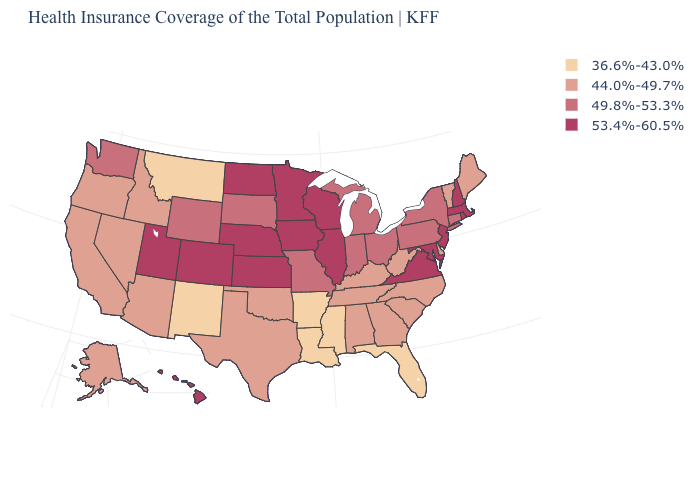Does the map have missing data?
Give a very brief answer. No. Is the legend a continuous bar?
Give a very brief answer. No. What is the value of Hawaii?
Keep it brief. 53.4%-60.5%. What is the value of Alaska?
Concise answer only. 44.0%-49.7%. Does California have the same value as Kentucky?
Answer briefly. Yes. Does the first symbol in the legend represent the smallest category?
Quick response, please. Yes. What is the value of Maryland?
Keep it brief. 53.4%-60.5%. What is the value of New Jersey?
Give a very brief answer. 53.4%-60.5%. What is the lowest value in the USA?
Write a very short answer. 36.6%-43.0%. What is the value of Florida?
Answer briefly. 36.6%-43.0%. Name the states that have a value in the range 36.6%-43.0%?
Concise answer only. Arkansas, Florida, Louisiana, Mississippi, Montana, New Mexico. Does New York have a higher value than Maryland?
Concise answer only. No. What is the value of North Dakota?
Be succinct. 53.4%-60.5%. Which states have the lowest value in the USA?
Quick response, please. Arkansas, Florida, Louisiana, Mississippi, Montana, New Mexico. Which states have the lowest value in the Northeast?
Short answer required. Maine, Vermont. 